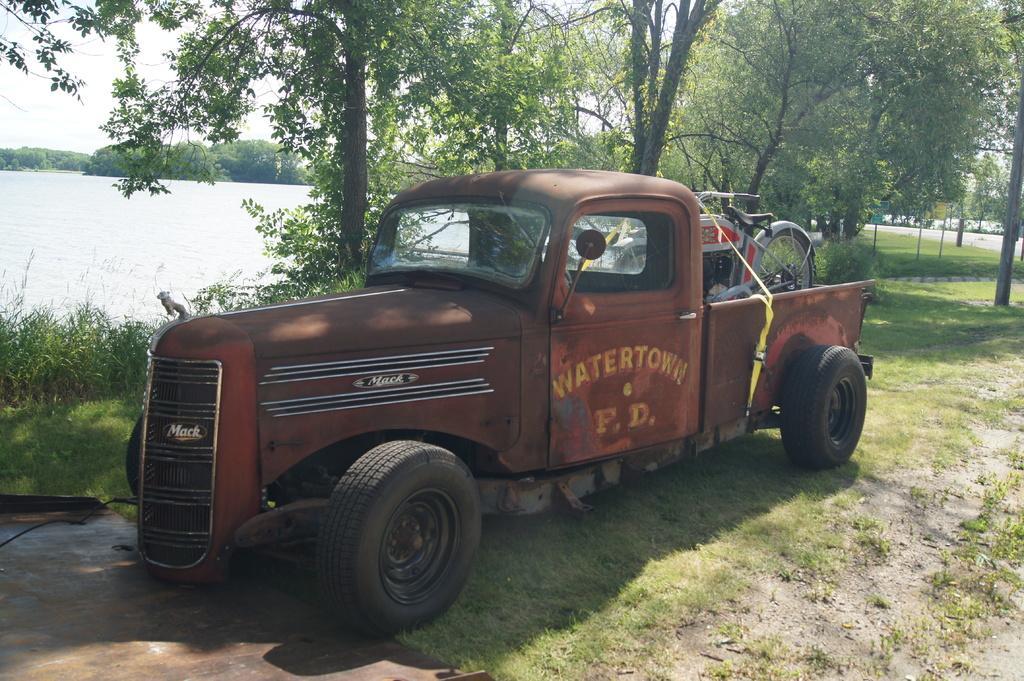Please provide a concise description of this image. In this picture there is a vehicle in the foreground and there is text on the vehicle and there is a motor bike on the vehicle. At the back there are trees and there are poles and there is a board on the pole and there is water. At the top there is sky. At the bottom there is grass and there are plants. At the bottom left there is a metal object. 